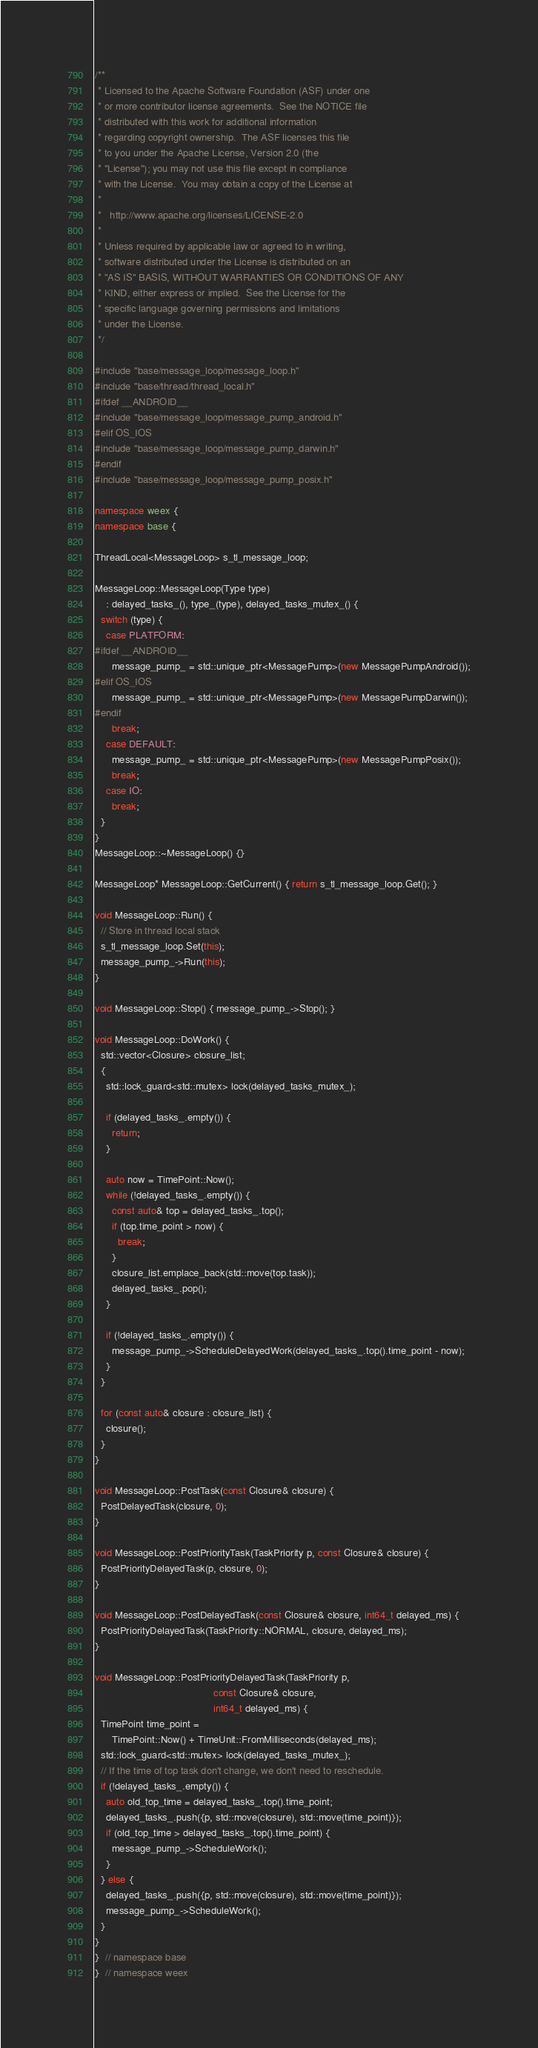Convert code to text. <code><loc_0><loc_0><loc_500><loc_500><_C++_>/**
 * Licensed to the Apache Software Foundation (ASF) under one
 * or more contributor license agreements.  See the NOTICE file
 * distributed with this work for additional information
 * regarding copyright ownership.  The ASF licenses this file
 * to you under the Apache License, Version 2.0 (the
 * "License"); you may not use this file except in compliance
 * with the License.  You may obtain a copy of the License at
 *
 *   http://www.apache.org/licenses/LICENSE-2.0
 *
 * Unless required by applicable law or agreed to in writing,
 * software distributed under the License is distributed on an
 * "AS IS" BASIS, WITHOUT WARRANTIES OR CONDITIONS OF ANY
 * KIND, either express or implied.  See the License for the
 * specific language governing permissions and limitations
 * under the License.
 */

#include "base/message_loop/message_loop.h"
#include "base/thread/thread_local.h"
#ifdef __ANDROID__
#include "base/message_loop/message_pump_android.h"
#elif OS_IOS
#include "base/message_loop/message_pump_darwin.h"
#endif
#include "base/message_loop/message_pump_posix.h"

namespace weex {
namespace base {

ThreadLocal<MessageLoop> s_tl_message_loop;

MessageLoop::MessageLoop(Type type)
    : delayed_tasks_(), type_(type), delayed_tasks_mutex_() {
  switch (type) {
    case PLATFORM:
#ifdef __ANDROID__ 
      message_pump_ = std::unique_ptr<MessagePump>(new MessagePumpAndroid());
#elif OS_IOS
      message_pump_ = std::unique_ptr<MessagePump>(new MessagePumpDarwin());
#endif
      break;
    case DEFAULT:
      message_pump_ = std::unique_ptr<MessagePump>(new MessagePumpPosix());
      break;
    case IO:
      break;
  }
}
MessageLoop::~MessageLoop() {}

MessageLoop* MessageLoop::GetCurrent() { return s_tl_message_loop.Get(); }

void MessageLoop::Run() {
  // Store in thread local stack
  s_tl_message_loop.Set(this);
  message_pump_->Run(this);
}

void MessageLoop::Stop() { message_pump_->Stop(); }

void MessageLoop::DoWork() {
  std::vector<Closure> closure_list;
  {
    std::lock_guard<std::mutex> lock(delayed_tasks_mutex_);

    if (delayed_tasks_.empty()) {
      return;
    }

    auto now = TimePoint::Now();
    while (!delayed_tasks_.empty()) {
      const auto& top = delayed_tasks_.top();
      if (top.time_point > now) {
        break;
      }
      closure_list.emplace_back(std::move(top.task));
      delayed_tasks_.pop();
    }

    if (!delayed_tasks_.empty()) {
      message_pump_->ScheduleDelayedWork(delayed_tasks_.top().time_point - now);
    }
  }

  for (const auto& closure : closure_list) {
    closure();
  }
}

void MessageLoop::PostTask(const Closure& closure) {
  PostDelayedTask(closure, 0);
}

void MessageLoop::PostPriorityTask(TaskPriority p, const Closure& closure) {
  PostPriorityDelayedTask(p, closure, 0);
}

void MessageLoop::PostDelayedTask(const Closure& closure, int64_t delayed_ms) {
  PostPriorityDelayedTask(TaskPriority::NORMAL, closure, delayed_ms);
}

void MessageLoop::PostPriorityDelayedTask(TaskPriority p,
                                          const Closure& closure,
                                          int64_t delayed_ms) {
  TimePoint time_point =
      TimePoint::Now() + TimeUnit::FromMilliseconds(delayed_ms);
  std::lock_guard<std::mutex> lock(delayed_tasks_mutex_);
  // If the time of top task don't change, we don't need to reschedule.
  if (!delayed_tasks_.empty()) {
    auto old_top_time = delayed_tasks_.top().time_point;
    delayed_tasks_.push({p, std::move(closure), std::move(time_point)});
    if (old_top_time > delayed_tasks_.top().time_point) {
      message_pump_->ScheduleWork();
    }
  } else {
    delayed_tasks_.push({p, std::move(closure), std::move(time_point)});
    message_pump_->ScheduleWork();
  }
}
}  // namespace base
}  // namespace weex
</code> 